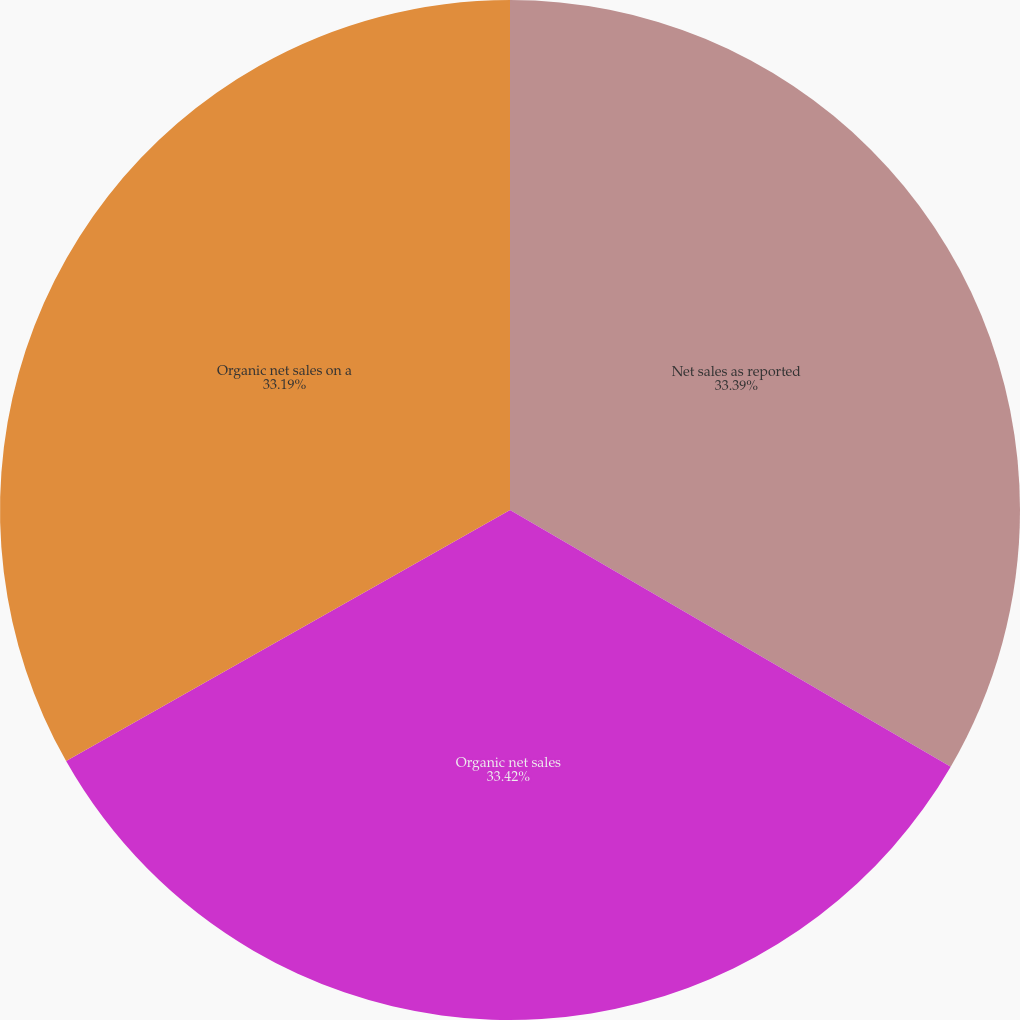Convert chart. <chart><loc_0><loc_0><loc_500><loc_500><pie_chart><fcel>Net sales as reported<fcel>Organic net sales<fcel>Organic net sales on a<nl><fcel>33.39%<fcel>33.41%<fcel>33.19%<nl></chart> 